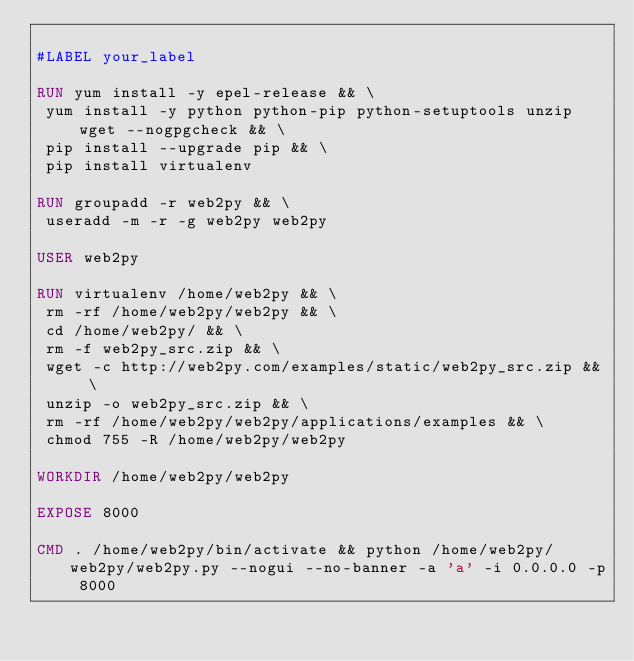<code> <loc_0><loc_0><loc_500><loc_500><_Dockerfile_>
#LABEL your_label

RUN yum install -y epel-release && \
 yum install -y python python-pip python-setuptools unzip wget --nogpgcheck && \
 pip install --upgrade pip && \
 pip install virtualenv 

RUN groupadd -r web2py && \
 useradd -m -r -g web2py web2py

USER web2py

RUN virtualenv /home/web2py && \
 rm -rf /home/web2py/web2py && \
 cd /home/web2py/ && \
 rm -f web2py_src.zip && \
 wget -c http://web2py.com/examples/static/web2py_src.zip && \
 unzip -o web2py_src.zip && \
 rm -rf /home/web2py/web2py/applications/examples && \
 chmod 755 -R /home/web2py/web2py

WORKDIR /home/web2py/web2py

EXPOSE 8000

CMD . /home/web2py/bin/activate && python /home/web2py/web2py/web2py.py --nogui --no-banner -a 'a' -i 0.0.0.0 -p 8000
</code> 